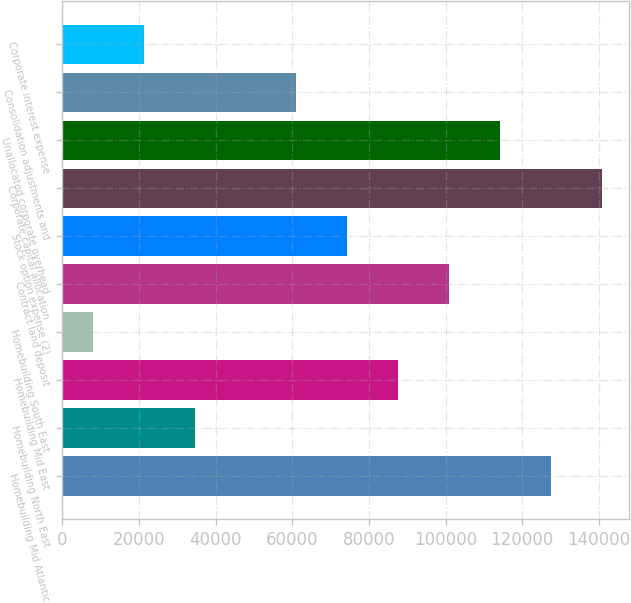Convert chart. <chart><loc_0><loc_0><loc_500><loc_500><bar_chart><fcel>Homebuilding Mid Atlantic<fcel>Homebuilding North East<fcel>Homebuilding Mid East<fcel>Homebuilding South East<fcel>Contract land deposit<fcel>Stock option expense (2)<fcel>Corporate capital allocation<fcel>Unallocated corporate overhead<fcel>Consolidation adjustments and<fcel>Corporate interest expense<nl><fcel>127466<fcel>34473.4<fcel>87612.2<fcel>7904<fcel>100897<fcel>74327.5<fcel>140751<fcel>114182<fcel>61042.8<fcel>21188.7<nl></chart> 